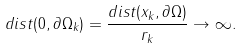Convert formula to latex. <formula><loc_0><loc_0><loc_500><loc_500>d i s t ( 0 , \partial \Omega _ { k } ) = \frac { d i s t ( x _ { k } , \partial \Omega ) } { r _ { k } } \to \infty .</formula> 